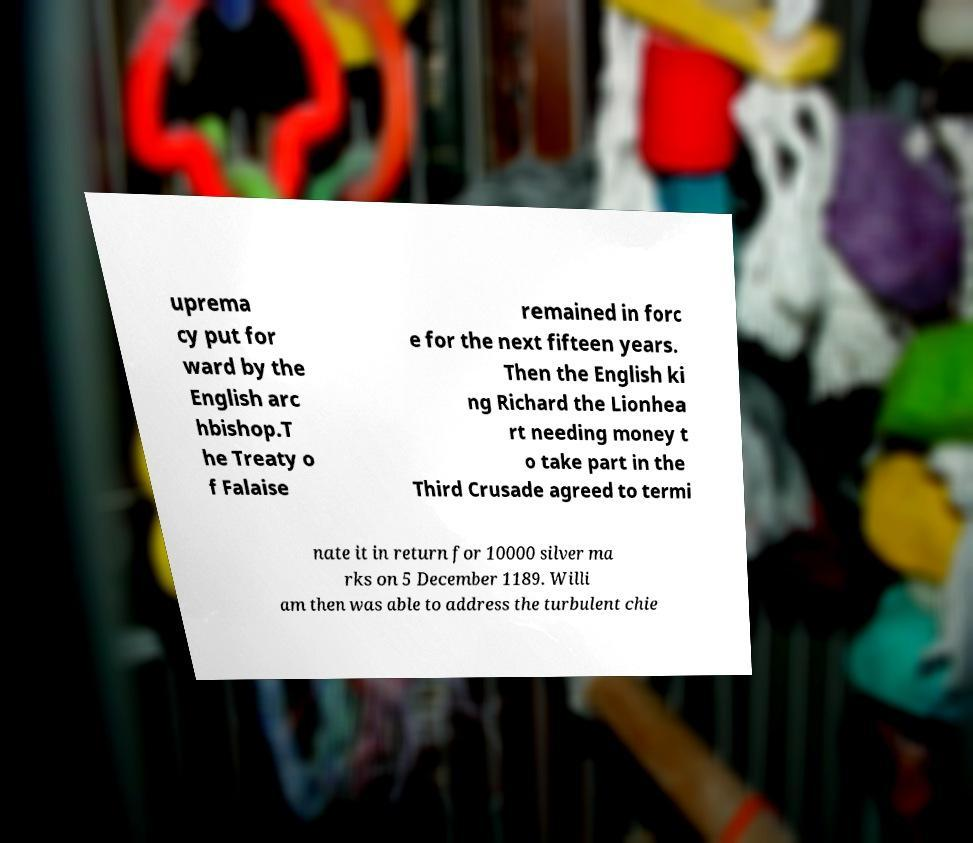Please identify and transcribe the text found in this image. uprema cy put for ward by the English arc hbishop.T he Treaty o f Falaise remained in forc e for the next fifteen years. Then the English ki ng Richard the Lionhea rt needing money t o take part in the Third Crusade agreed to termi nate it in return for 10000 silver ma rks on 5 December 1189. Willi am then was able to address the turbulent chie 